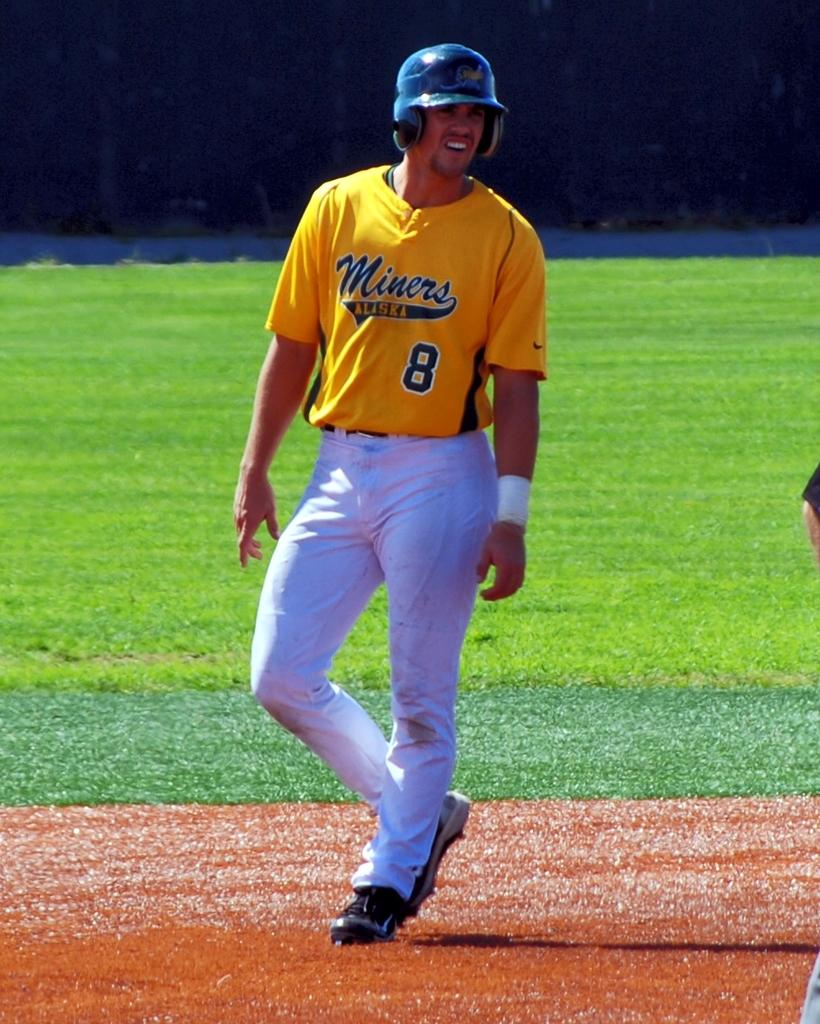<image>
Share a concise interpretation of the image provided. Number 8 for the Miners baseball team looks like he just got a hit. 